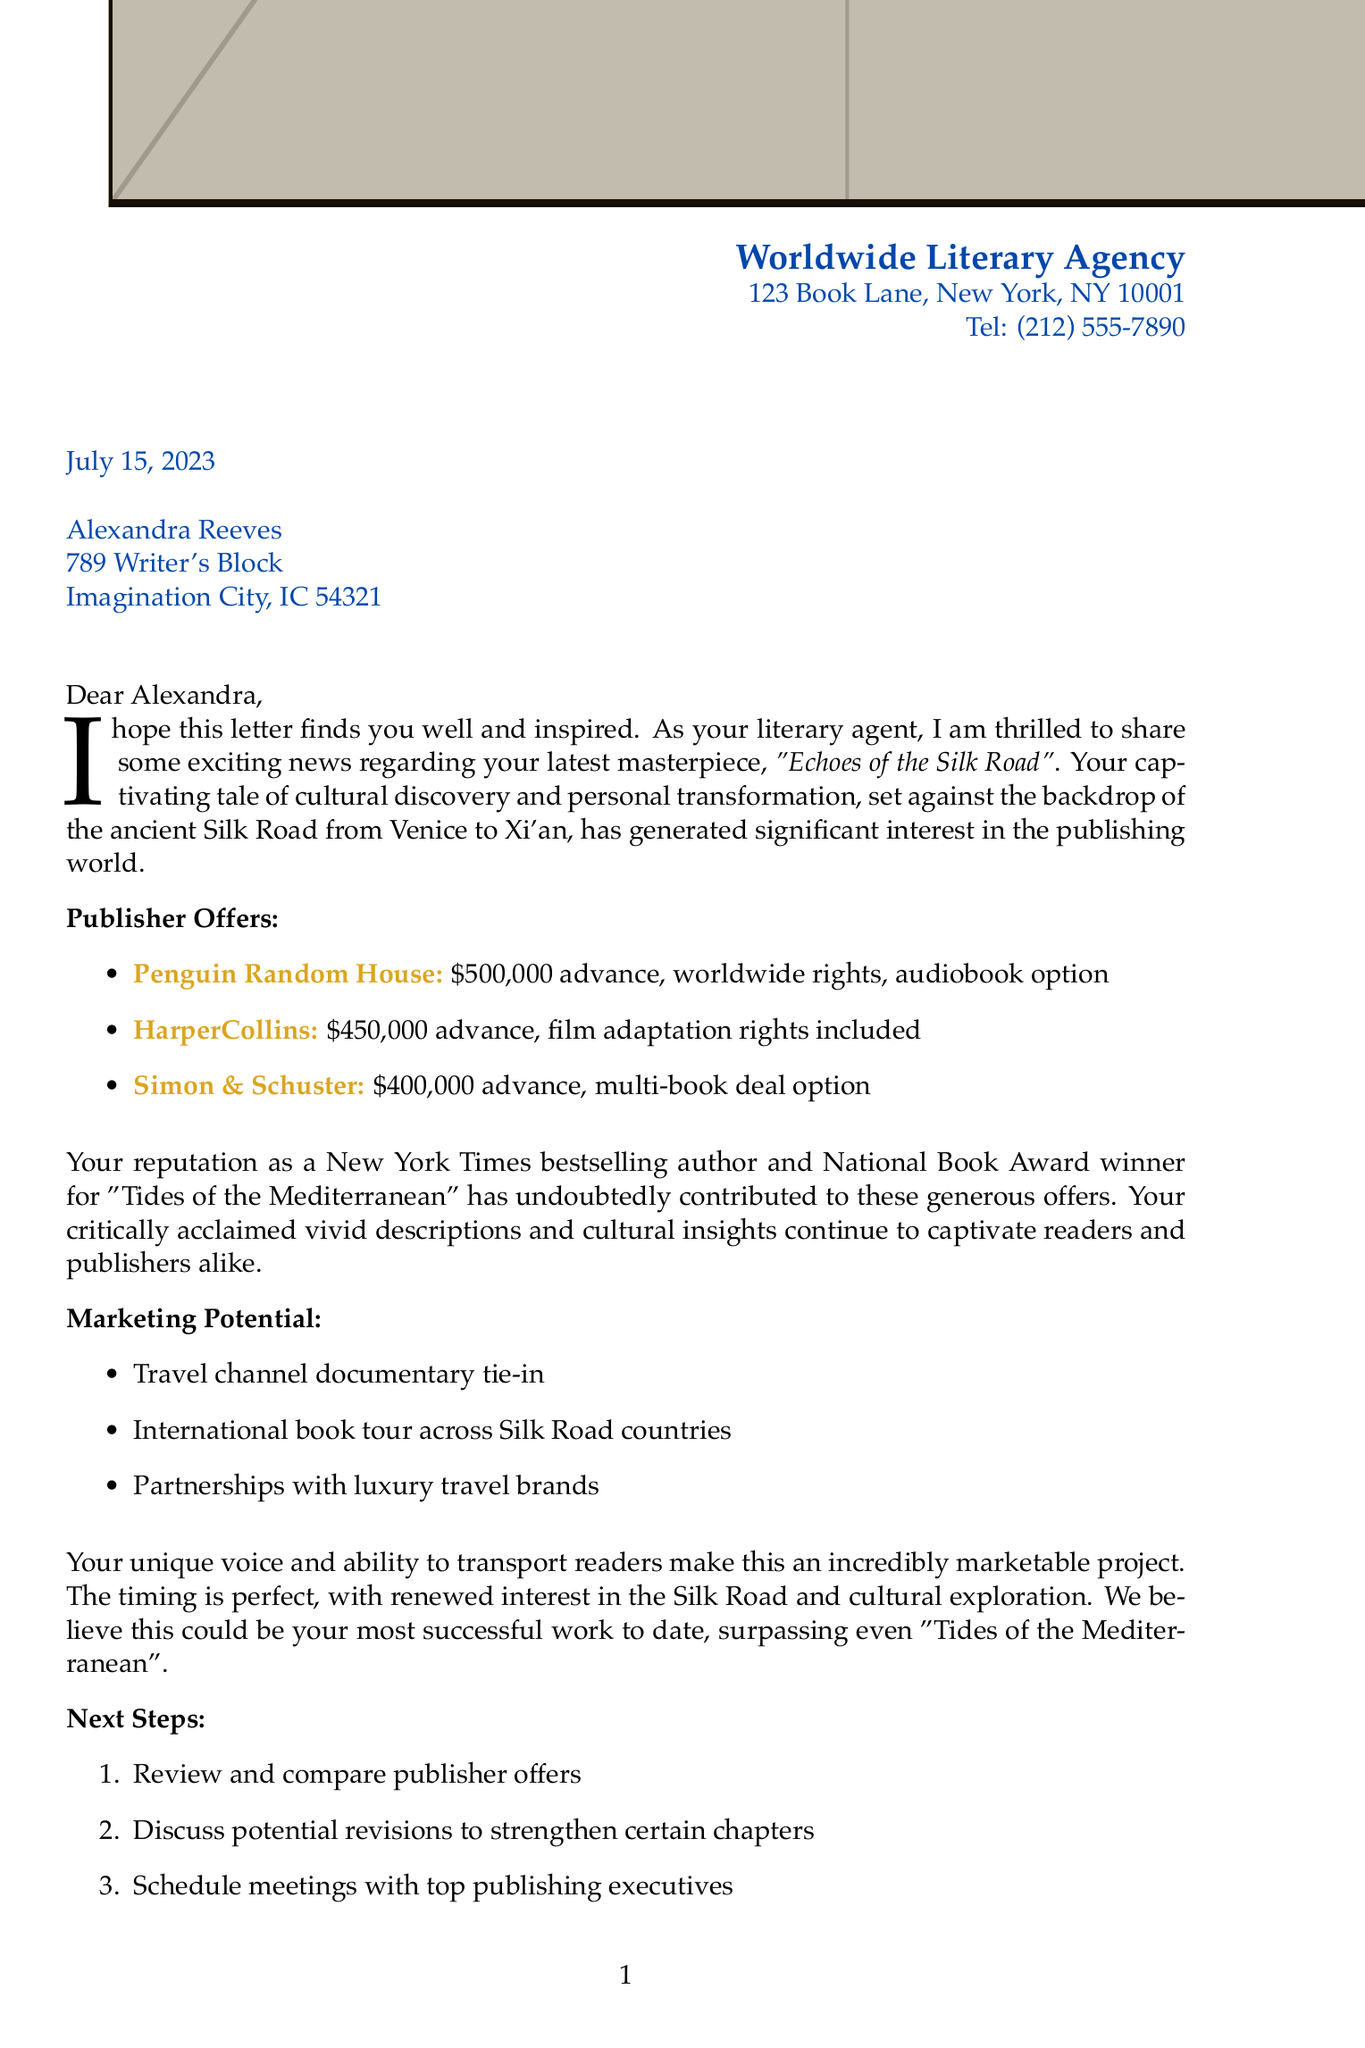What is the title of the novel? The title of the novel is stated directly in the document.
Answer: Echoes of the Silk Road Who is the literary agent? The letter clearly identifies the sender, who is the literary agent.
Answer: Sarah Thompson What is the advance offered by Penguin Random House? The advance offer from Penguin Random House is explicitly listed in the document.
Answer: $500,000 advance What marketing potential is mentioned in the letter? The marketing potential includes various strategies mentioned in the letter that indicate how the book could be promoted.
Answer: Travel channel documentary tie-in How many weeks do we have to make a publisher decision? The letter articulates a timeline for decision-making regarding publisher offers, specifying the duration.
Answer: Within 2 weeks What notable award has the author won? The letter references a specific award that highlights the author's achievements in writing.
Answer: National Book Award What is the projected release date of the novel? The projected release date is mentioned towards the end of the letter, summarizing expected timelines.
Answer: Spring of next year What do the agent's comments suggest about the book's potential? The agent’s comments provide insights into her views on the uniqueness and marketability of the book based on her evaluation.
Answer: Incredibly marketable project How many publishers made offers for the novel? By counting the entities listed under publisher offers in the document, we can see the total number mentioned.
Answer: Three publishers 